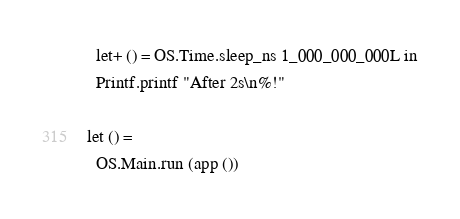Convert code to text. <code><loc_0><loc_0><loc_500><loc_500><_OCaml_>  let+ () = OS.Time.sleep_ns 1_000_000_000L in
  Printf.printf "After 2s\n%!"

let () =
  OS.Main.run (app ())
</code> 